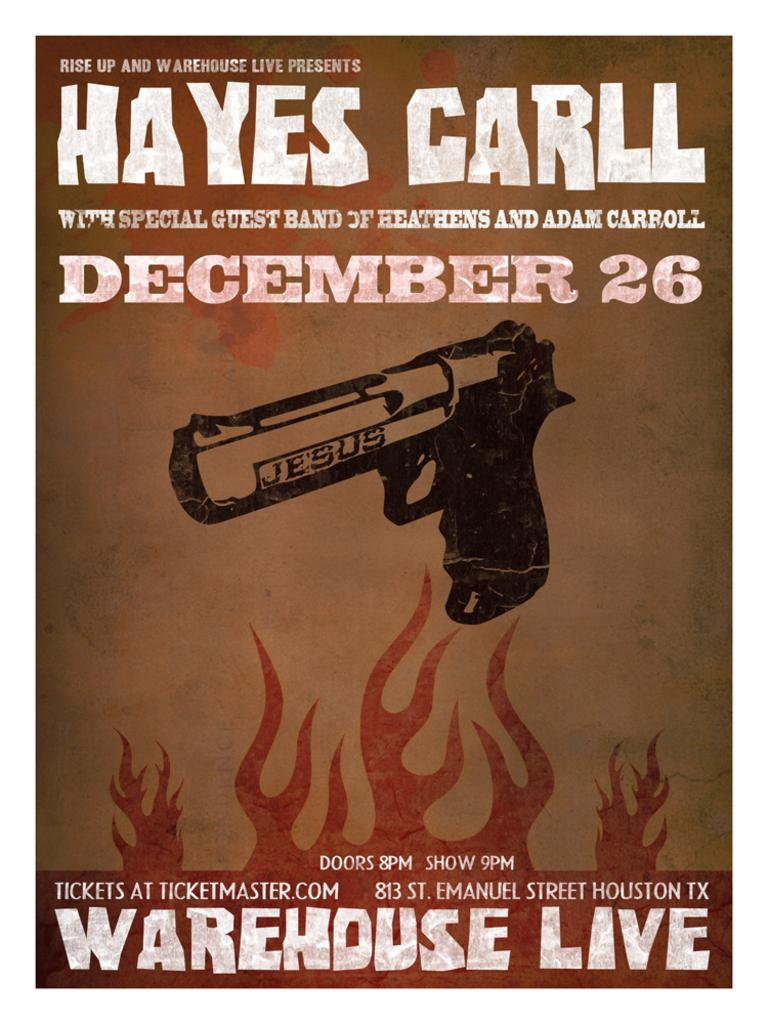What is the main object in the center of the image? There is a gun in the center of the image. What type of text can be seen at the top of the image? There is text at the top of the image. What type of text can be seen at the bottom of the image? There is text at the bottom of the image. What might the image be used for? The image might be a poster. How many clovers are visible in the image? There are no clovers present in the image. What type of building is shown in the image? There is no building shown in the image. 